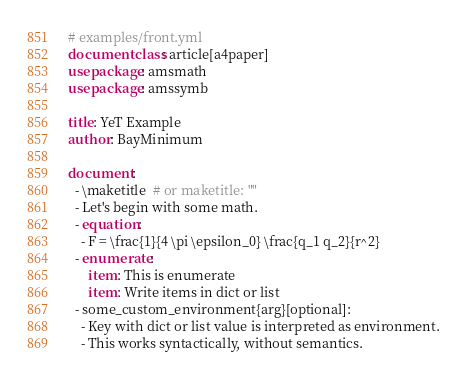Convert code to text. <code><loc_0><loc_0><loc_500><loc_500><_YAML_># examples/front.yml
documentclass: article[a4paper]
usepackage: amsmath
usepackage: amssymb

title: YeT Example
author: BayMinimum

document:
  - \maketitle  # or maketitle: ""
  - Let's begin with some math.
  - equation:
    - F = \frac{1}{4 \pi \epsilon_0} \frac{q_1 q_2}{r^2}
  - enumerate:
      item: This is enumerate
      item: Write items in dict or list
  - some_custom_environment{arg}[optional]:
    - Key with dict or list value is interpreted as environment.
    - This works syntactically, without semantics.
</code> 